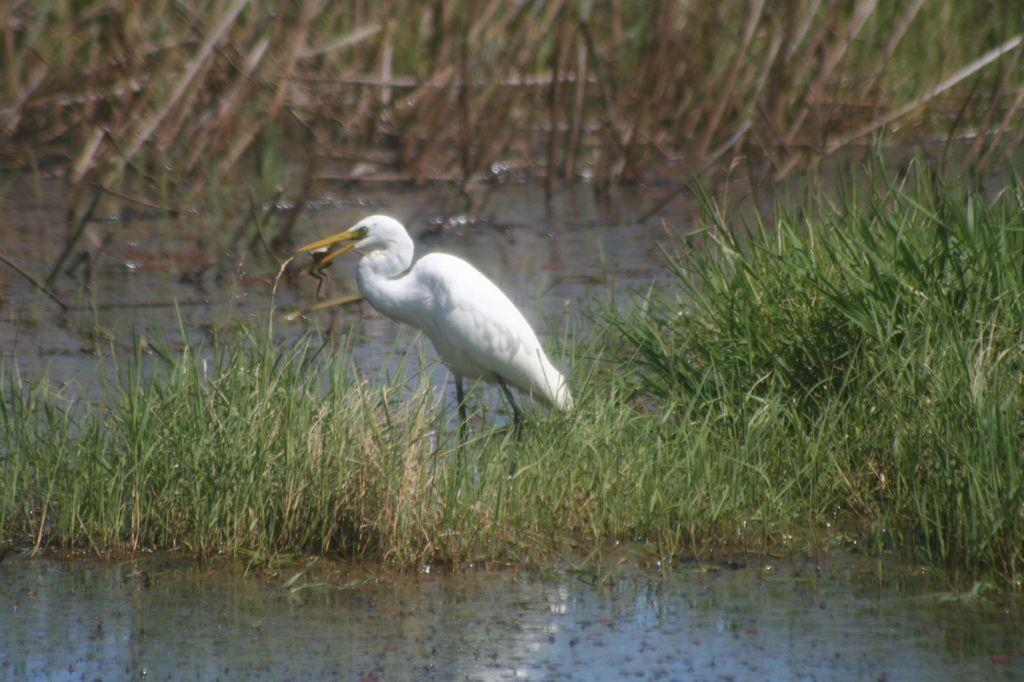What is the main subject in the center of the image? There is a crane in the center of the image. Where is the crane located? The crane is on the grass. What can be seen at the bottom of the image? There is water at the bottom of the image. What type of vegetation is visible in the background of the image? There are plants in the background of the image. What type of house can be seen in the background of the image? There is no house visible in the background of the image; it features plants instead. What activity is the crane performing in the image? The image does not show the crane performing any specific activity; it is simply located on the grass. 